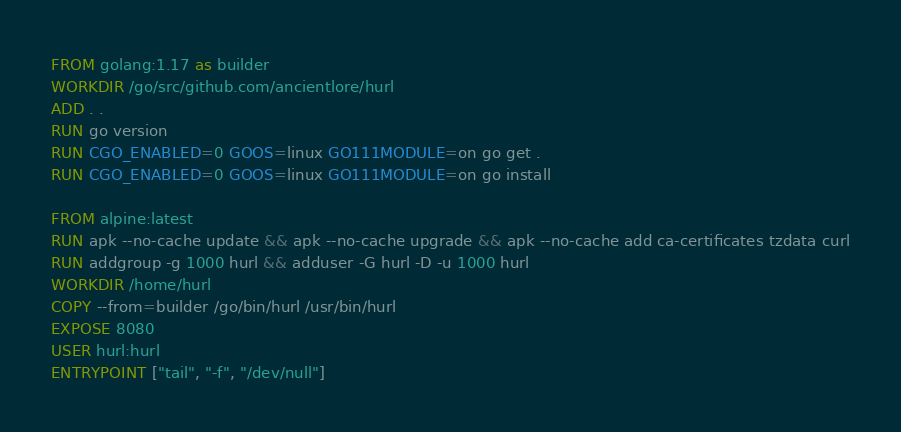Convert code to text. <code><loc_0><loc_0><loc_500><loc_500><_Dockerfile_>FROM golang:1.17 as builder
WORKDIR /go/src/github.com/ancientlore/hurl
ADD . .
RUN go version
RUN CGO_ENABLED=0 GOOS=linux GO111MODULE=on go get .
RUN CGO_ENABLED=0 GOOS=linux GO111MODULE=on go install

FROM alpine:latest
RUN apk --no-cache update && apk --no-cache upgrade && apk --no-cache add ca-certificates tzdata curl
RUN addgroup -g 1000 hurl && adduser -G hurl -D -u 1000 hurl 
WORKDIR /home/hurl
COPY --from=builder /go/bin/hurl /usr/bin/hurl
EXPOSE 8080
USER hurl:hurl
ENTRYPOINT ["tail", "-f", "/dev/null"]
</code> 